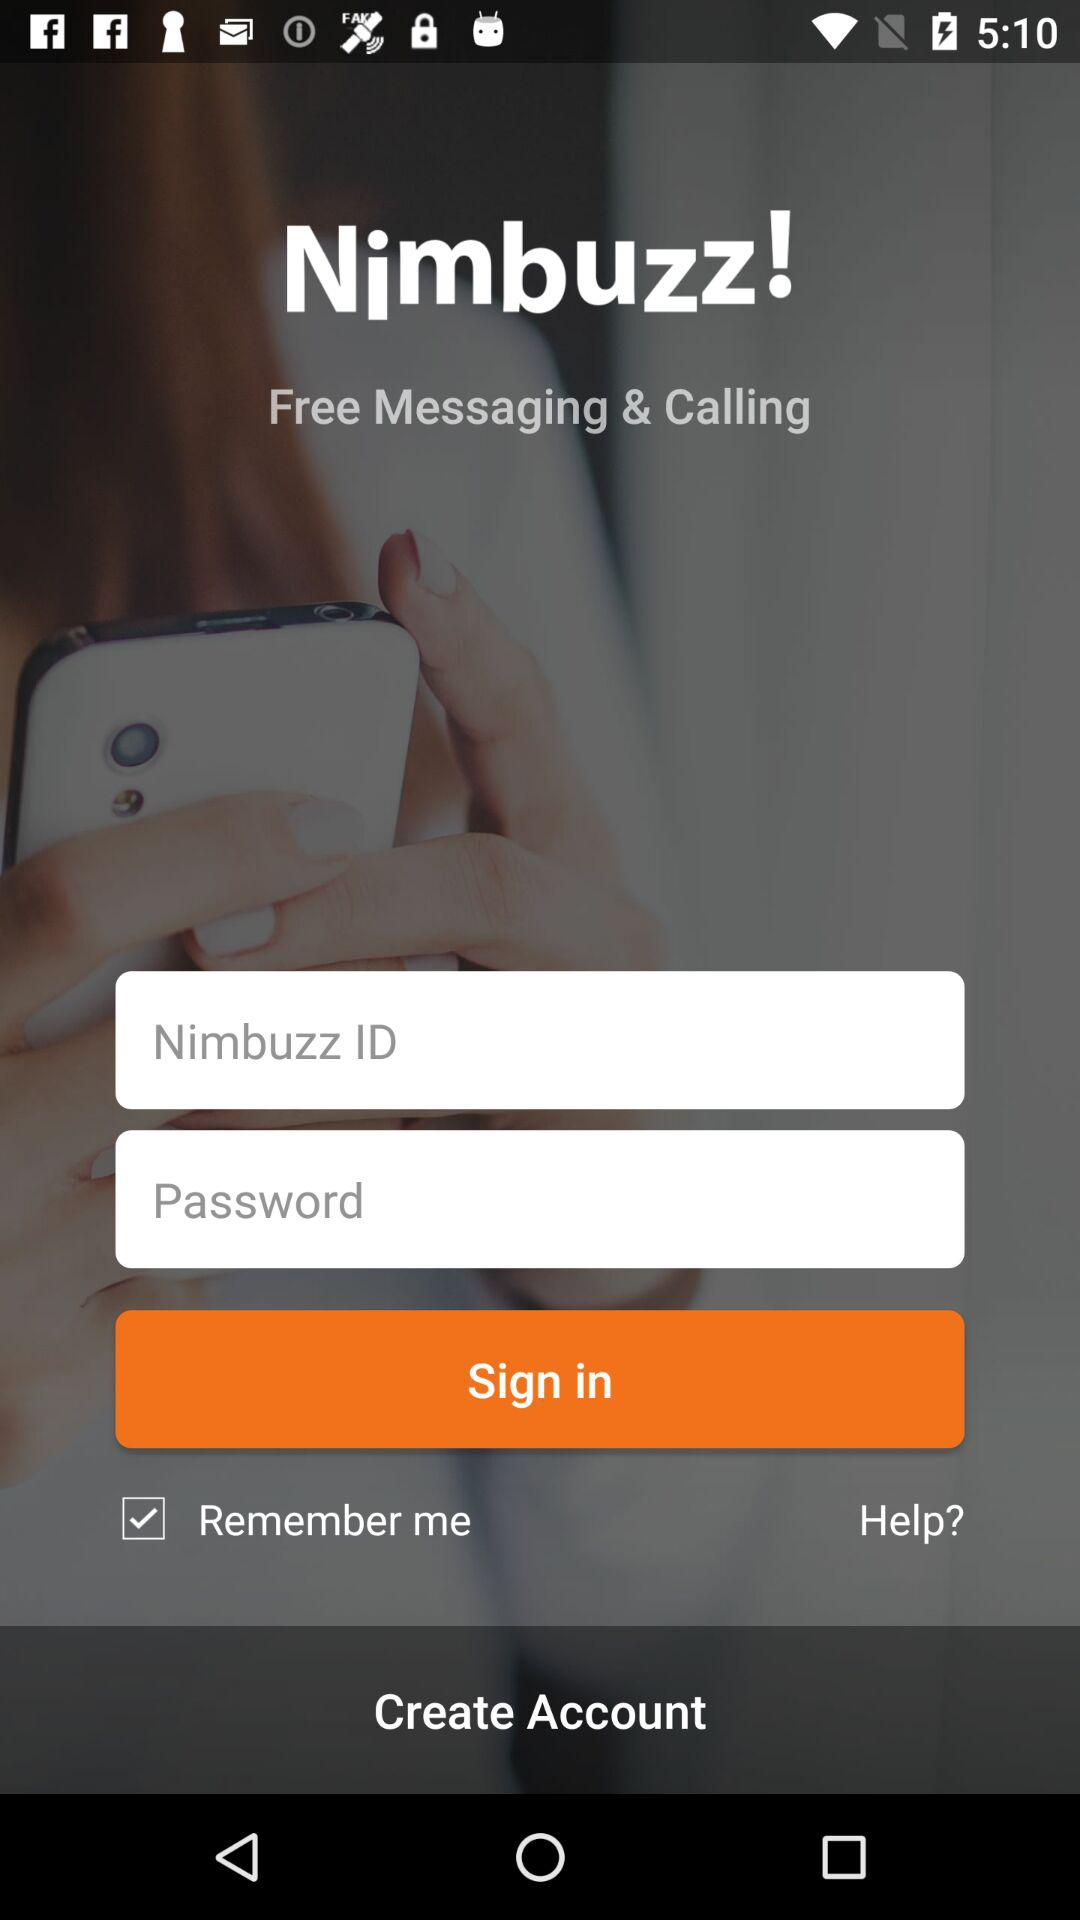What are the requirements to sign in? The requirements to sign in are "Nimbuzz ID" and "Password". 